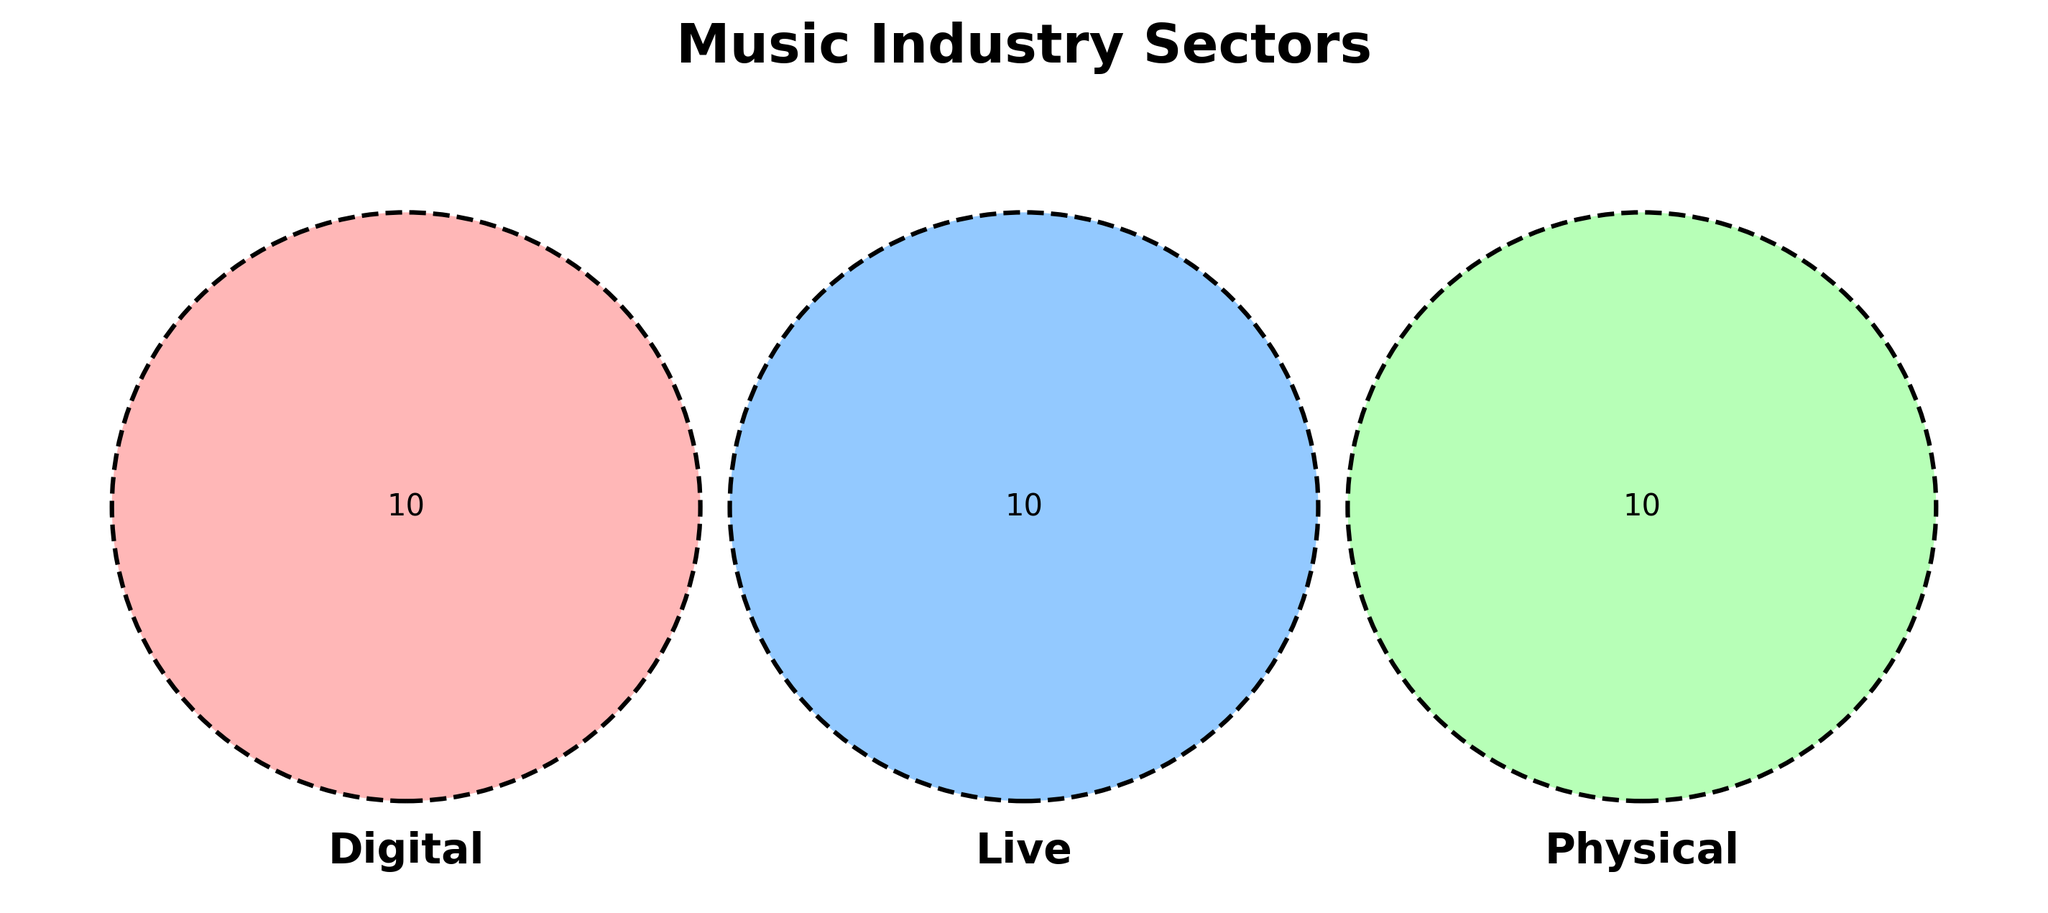What are the three main sectors shown in the title? The title "Music Industry Sectors" suggests the three main categories being analyzed.
Answer: Digital, Live, Physical How many elements are uniquely associated with the Digital sector? Only the section of the Venn Diagram corresponding to Digital and not overlapping with Live or Physical shows unique elements.
Answer: 7 Which sectors contain elements that overlap with both Live and Physical? The intersection area between Live and Physical, excluding Digital, indicates overlapping elements.
Answer: None How many elements are shared by both the Live and Physical sectors? Look at the overlapping area between the circles representing Live and Physical.
Answer: 0 What is the only element that overlaps with all three sectors (Digital, Live, and Physical)? Identify the shared section where all three circles intersect in the Venn Diagram.
Answer: None Which sector has the highest number of unique elements? Compare the number of unique elements in each circle of the Venn Diagram.
Answer: Digital What unique elements are found in the Live sector that are not in Digital or Physical? Identify the elements in the Live circle that do not overlap with either of the other two circles.
Answer: Coachella, Glastonbury, Tomorrowland, SXSW, Lollapalooza, Burning Man, Stadium Tours, Music Festivals, Busking, Club Gigs Are there elements shared between Digital and Physical sectors? Check the overlapping area between the Digital and Physical circles.
Answer: No What is the combined number of unique elements from both the Digital and Live sectors? Adding the unique elements from the Digital and Live sectors. There are 7 unique elements in Digital and 10 unique elements in Live.
Answer: 17 